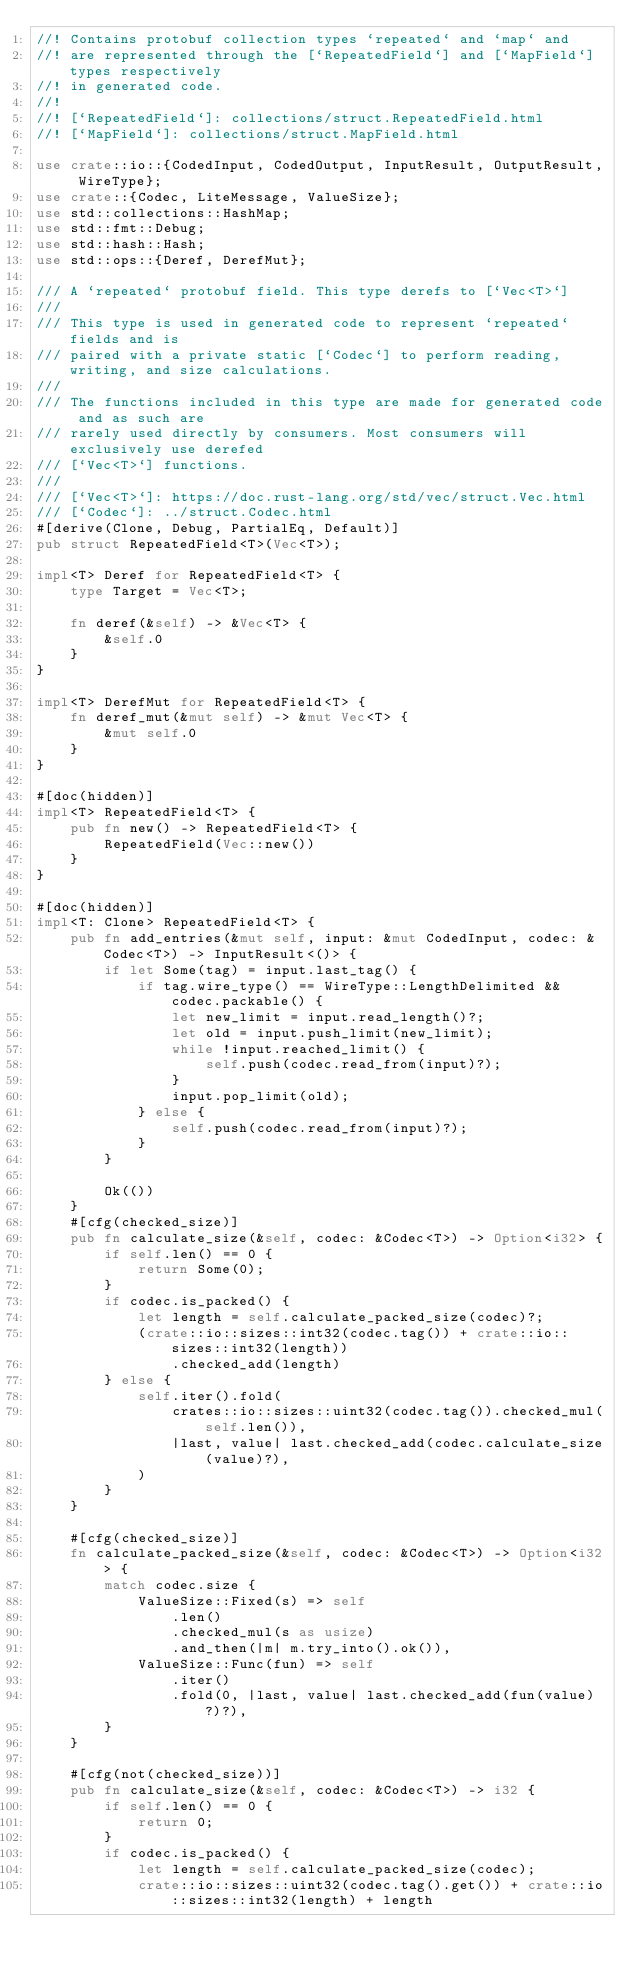Convert code to text. <code><loc_0><loc_0><loc_500><loc_500><_Rust_>//! Contains protobuf collection types `repeated` and `map` and
//! are represented through the [`RepeatedField`] and [`MapField`] types respectively
//! in generated code.
//!
//! [`RepeatedField`]: collections/struct.RepeatedField.html
//! [`MapField`]: collections/struct.MapField.html

use crate::io::{CodedInput, CodedOutput, InputResult, OutputResult, WireType};
use crate::{Codec, LiteMessage, ValueSize};
use std::collections::HashMap;
use std::fmt::Debug;
use std::hash::Hash;
use std::ops::{Deref, DerefMut};

/// A `repeated` protobuf field. This type derefs to [`Vec<T>`]
///
/// This type is used in generated code to represent `repeated` fields and is
/// paired with a private static [`Codec`] to perform reading, writing, and size calculations.
///
/// The functions included in this type are made for generated code and as such are
/// rarely used directly by consumers. Most consumers will exclusively use derefed
/// [`Vec<T>`] functions.
///
/// [`Vec<T>`]: https://doc.rust-lang.org/std/vec/struct.Vec.html
/// [`Codec`]: ../struct.Codec.html
#[derive(Clone, Debug, PartialEq, Default)]
pub struct RepeatedField<T>(Vec<T>);

impl<T> Deref for RepeatedField<T> {
    type Target = Vec<T>;

    fn deref(&self) -> &Vec<T> {
        &self.0
    }
}

impl<T> DerefMut for RepeatedField<T> {
    fn deref_mut(&mut self) -> &mut Vec<T> {
        &mut self.0
    }
}

#[doc(hidden)]
impl<T> RepeatedField<T> {
    pub fn new() -> RepeatedField<T> {
        RepeatedField(Vec::new())
    }
}

#[doc(hidden)]
impl<T: Clone> RepeatedField<T> {
    pub fn add_entries(&mut self, input: &mut CodedInput, codec: &Codec<T>) -> InputResult<()> {
        if let Some(tag) = input.last_tag() {
            if tag.wire_type() == WireType::LengthDelimited && codec.packable() {
                let new_limit = input.read_length()?;
                let old = input.push_limit(new_limit);
                while !input.reached_limit() {
                    self.push(codec.read_from(input)?);
                }
                input.pop_limit(old);
            } else {
                self.push(codec.read_from(input)?);
            }
        }

        Ok(())
    }
    #[cfg(checked_size)]
    pub fn calculate_size(&self, codec: &Codec<T>) -> Option<i32> {
        if self.len() == 0 {
            return Some(0);
        }
        if codec.is_packed() {
            let length = self.calculate_packed_size(codec)?;
            (crate::io::sizes::int32(codec.tag()) + crate::io::sizes::int32(length))
                .checked_add(length)
        } else {
            self.iter().fold(
                crates::io::sizes::uint32(codec.tag()).checked_mul(self.len()),
                |last, value| last.checked_add(codec.calculate_size(value)?),
            )
        }
    }

    #[cfg(checked_size)]
    fn calculate_packed_size(&self, codec: &Codec<T>) -> Option<i32> {
        match codec.size {
            ValueSize::Fixed(s) => self
                .len()
                .checked_mul(s as usize)
                .and_then(|m| m.try_into().ok()),
            ValueSize::Func(fun) => self
                .iter()
                .fold(0, |last, value| last.checked_add(fun(value)?)?),
        }
    }

    #[cfg(not(checked_size))]
    pub fn calculate_size(&self, codec: &Codec<T>) -> i32 {
        if self.len() == 0 {
            return 0;
        }
        if codec.is_packed() {
            let length = self.calculate_packed_size(codec);
            crate::io::sizes::uint32(codec.tag().get()) + crate::io::sizes::int32(length) + length</code> 